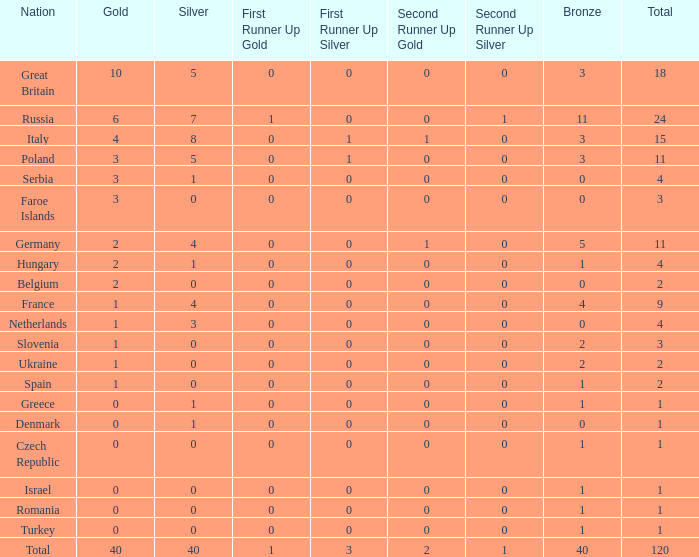What Nation has a Gold entry that is greater than 0, a Total that is greater than 2, a Silver entry that is larger than 1, and 0 Bronze? Netherlands. 